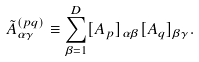Convert formula to latex. <formula><loc_0><loc_0><loc_500><loc_500>\tilde { A } ^ { ( p q ) } _ { \alpha \gamma } \equiv \sum _ { \beta = 1 } ^ { D } [ A _ { p } ] _ { \alpha \beta } [ A _ { q } ] _ { \beta \gamma } .</formula> 